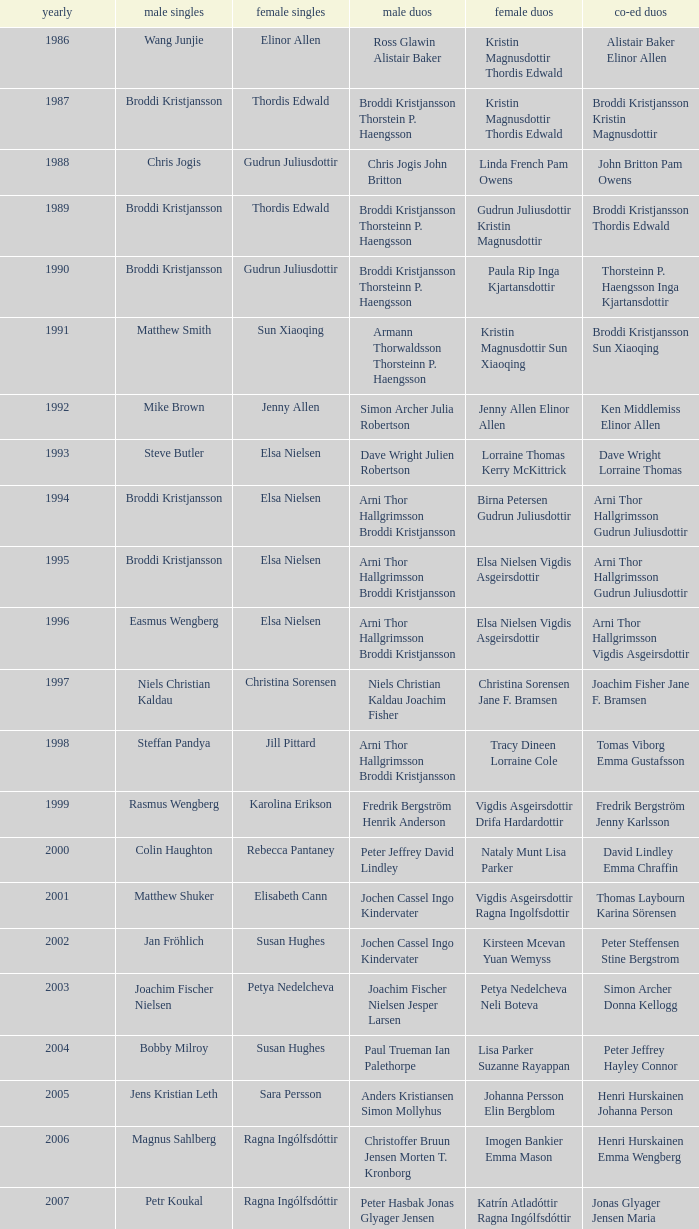Would you be able to parse every entry in this table? {'header': ['yearly', 'male singles', 'female singles', 'male duos', 'female duos', 'co-ed duos'], 'rows': [['1986', 'Wang Junjie', 'Elinor Allen', 'Ross Glawin Alistair Baker', 'Kristin Magnusdottir Thordis Edwald', 'Alistair Baker Elinor Allen'], ['1987', 'Broddi Kristjansson', 'Thordis Edwald', 'Broddi Kristjansson Thorstein P. Haengsson', 'Kristin Magnusdottir Thordis Edwald', 'Broddi Kristjansson Kristin Magnusdottir'], ['1988', 'Chris Jogis', 'Gudrun Juliusdottir', 'Chris Jogis John Britton', 'Linda French Pam Owens', 'John Britton Pam Owens'], ['1989', 'Broddi Kristjansson', 'Thordis Edwald', 'Broddi Kristjansson Thorsteinn P. Haengsson', 'Gudrun Juliusdottir Kristin Magnusdottir', 'Broddi Kristjansson Thordis Edwald'], ['1990', 'Broddi Kristjansson', 'Gudrun Juliusdottir', 'Broddi Kristjansson Thorsteinn P. Haengsson', 'Paula Rip Inga Kjartansdottir', 'Thorsteinn P. Haengsson Inga Kjartansdottir'], ['1991', 'Matthew Smith', 'Sun Xiaoqing', 'Armann Thorwaldsson Thorsteinn P. Haengsson', 'Kristin Magnusdottir Sun Xiaoqing', 'Broddi Kristjansson Sun Xiaoqing'], ['1992', 'Mike Brown', 'Jenny Allen', 'Simon Archer Julia Robertson', 'Jenny Allen Elinor Allen', 'Ken Middlemiss Elinor Allen'], ['1993', 'Steve Butler', 'Elsa Nielsen', 'Dave Wright Julien Robertson', 'Lorraine Thomas Kerry McKittrick', 'Dave Wright Lorraine Thomas'], ['1994', 'Broddi Kristjansson', 'Elsa Nielsen', 'Arni Thor Hallgrimsson Broddi Kristjansson', 'Birna Petersen Gudrun Juliusdottir', 'Arni Thor Hallgrimsson Gudrun Juliusdottir'], ['1995', 'Broddi Kristjansson', 'Elsa Nielsen', 'Arni Thor Hallgrimsson Broddi Kristjansson', 'Elsa Nielsen Vigdis Asgeirsdottir', 'Arni Thor Hallgrimsson Gudrun Juliusdottir'], ['1996', 'Easmus Wengberg', 'Elsa Nielsen', 'Arni Thor Hallgrimsson Broddi Kristjansson', 'Elsa Nielsen Vigdis Asgeirsdottir', 'Arni Thor Hallgrimsson Vigdis Asgeirsdottir'], ['1997', 'Niels Christian Kaldau', 'Christina Sorensen', 'Niels Christian Kaldau Joachim Fisher', 'Christina Sorensen Jane F. Bramsen', 'Joachim Fisher Jane F. Bramsen'], ['1998', 'Steffan Pandya', 'Jill Pittard', 'Arni Thor Hallgrimsson Broddi Kristjansson', 'Tracy Dineen Lorraine Cole', 'Tomas Viborg Emma Gustafsson'], ['1999', 'Rasmus Wengberg', 'Karolina Erikson', 'Fredrik Bergström Henrik Anderson', 'Vigdis Asgeirsdottir Drifa Hardardottir', 'Fredrik Bergström Jenny Karlsson'], ['2000', 'Colin Haughton', 'Rebecca Pantaney', 'Peter Jeffrey David Lindley', 'Nataly Munt Lisa Parker', 'David Lindley Emma Chraffin'], ['2001', 'Matthew Shuker', 'Elisabeth Cann', 'Jochen Cassel Ingo Kindervater', 'Vigdis Asgeirsdottir Ragna Ingolfsdottir', 'Thomas Laybourn Karina Sörensen'], ['2002', 'Jan Fröhlich', 'Susan Hughes', 'Jochen Cassel Ingo Kindervater', 'Kirsteen Mcevan Yuan Wemyss', 'Peter Steffensen Stine Bergstrom'], ['2003', 'Joachim Fischer Nielsen', 'Petya Nedelcheva', 'Joachim Fischer Nielsen Jesper Larsen', 'Petya Nedelcheva Neli Boteva', 'Simon Archer Donna Kellogg'], ['2004', 'Bobby Milroy', 'Susan Hughes', 'Paul Trueman Ian Palethorpe', 'Lisa Parker Suzanne Rayappan', 'Peter Jeffrey Hayley Connor'], ['2005', 'Jens Kristian Leth', 'Sara Persson', 'Anders Kristiansen Simon Mollyhus', 'Johanna Persson Elin Bergblom', 'Henri Hurskainen Johanna Person'], ['2006', 'Magnus Sahlberg', 'Ragna Ingólfsdóttir', 'Christoffer Bruun Jensen Morten T. Kronborg', 'Imogen Bankier Emma Mason', 'Henri Hurskainen Emma Wengberg'], ['2007', 'Petr Koukal', 'Ragna Ingólfsdóttir', 'Peter Hasbak Jonas Glyager Jensen', 'Katrín Atladóttir Ragna Ingólfsdóttir', 'Jonas Glyager Jensen Maria Kaaberböl Thorberg'], ['2008', 'No competition', 'No competition', 'No competition', 'No competition', 'No competition'], ['2009', 'Christian Lind Thomsen', 'Ragna Ingólfsdóttir', 'Anders Skaarup Rasmussen René Lindskow', 'Ragna Ingólfsdóttir Snjólaug Jóhannsdóttir', 'Theis Christiansen Joan Christiansen'], ['2010', 'Kim Bruun', 'Ragna Ingólfsdóttir', 'Emil Holst Mikkel Mikkelsen', 'Katrín Atladóttir Ragna Ingólfsdóttir', 'Frederik Colberg Mette Poulsen'], ['2011', 'Mathias Borg', 'Ragna Ingólfsdóttir', 'Thomas Dew-Hattens Mathias Kany', 'Tinna Helgadóttir Snjólaug Jóhannsdóttir', 'Thomas Dew-Hattens Louise Hansen'], ['2012', 'Chou Tien-chen', 'Chiang Mei-hui', 'Joe Morgan Nic Strange', 'Lee So-hee Shin Seung-chan', 'Chou Tien-chen Chiang Mei-hui']]} Which mixed doubles happened later than 2011? Chou Tien-chen Chiang Mei-hui. 